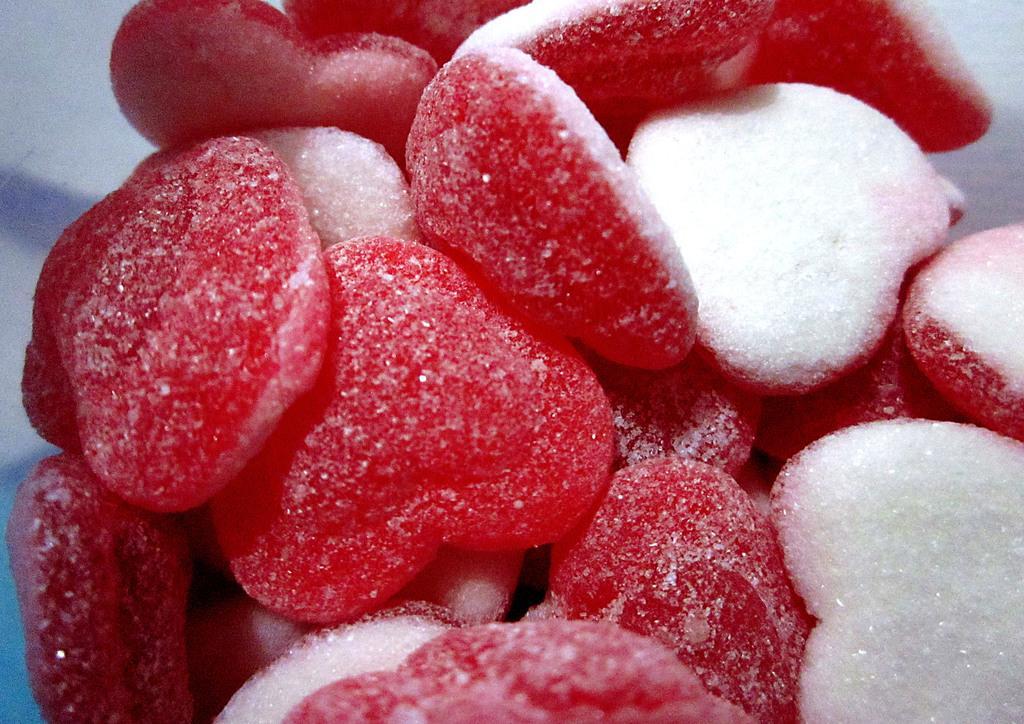Describe this image in one or two sentences. We can see red sugar candies. 